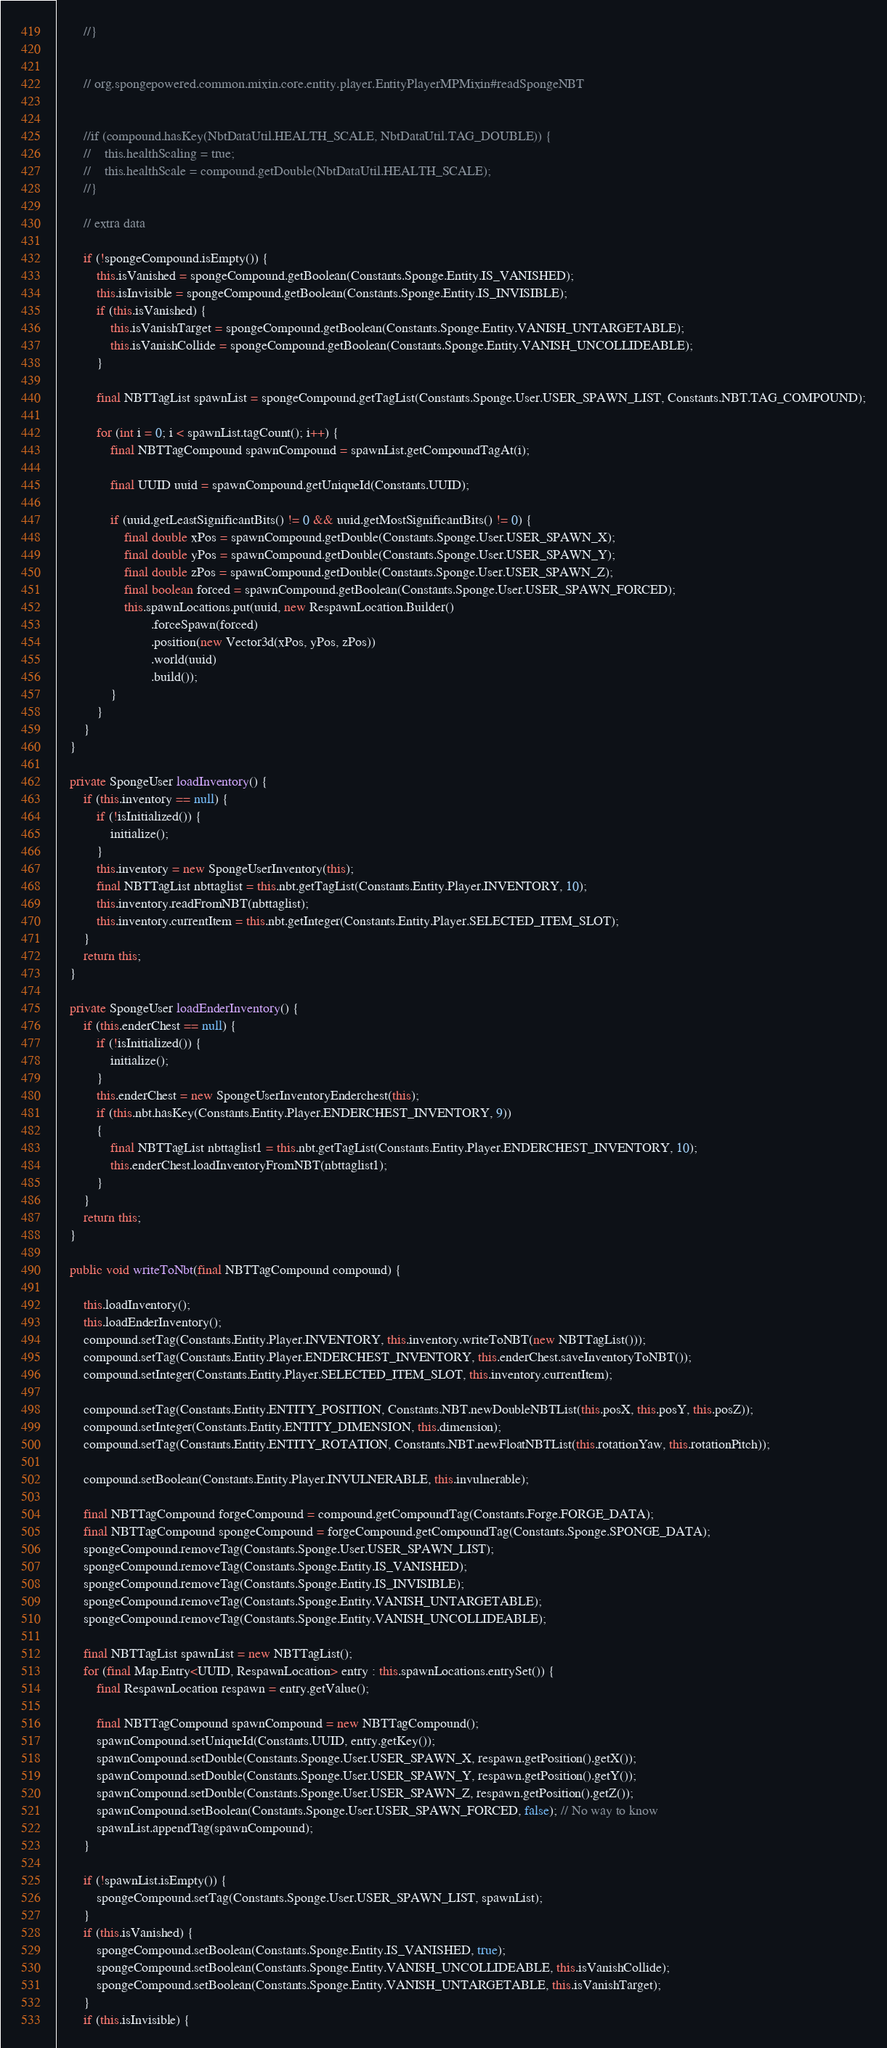Convert code to text. <code><loc_0><loc_0><loc_500><loc_500><_Java_>        //}


        // org.spongepowered.common.mixin.core.entity.player.EntityPlayerMPMixin#readSpongeNBT


        //if (compound.hasKey(NbtDataUtil.HEALTH_SCALE, NbtDataUtil.TAG_DOUBLE)) {
        //    this.healthScaling = true;
        //    this.healthScale = compound.getDouble(NbtDataUtil.HEALTH_SCALE);
        //}

        // extra data

        if (!spongeCompound.isEmpty()) {
            this.isVanished = spongeCompound.getBoolean(Constants.Sponge.Entity.IS_VANISHED);
            this.isInvisible = spongeCompound.getBoolean(Constants.Sponge.Entity.IS_INVISIBLE);
            if (this.isVanished) {
                this.isVanishTarget = spongeCompound.getBoolean(Constants.Sponge.Entity.VANISH_UNTARGETABLE);
                this.isVanishCollide = spongeCompound.getBoolean(Constants.Sponge.Entity.VANISH_UNCOLLIDEABLE);
            }

            final NBTTagList spawnList = spongeCompound.getTagList(Constants.Sponge.User.USER_SPAWN_LIST, Constants.NBT.TAG_COMPOUND);

            for (int i = 0; i < spawnList.tagCount(); i++) {
                final NBTTagCompound spawnCompound = spawnList.getCompoundTagAt(i);

                final UUID uuid = spawnCompound.getUniqueId(Constants.UUID);

                if (uuid.getLeastSignificantBits() != 0 && uuid.getMostSignificantBits() != 0) {
                    final double xPos = spawnCompound.getDouble(Constants.Sponge.User.USER_SPAWN_X);
                    final double yPos = spawnCompound.getDouble(Constants.Sponge.User.USER_SPAWN_Y);
                    final double zPos = spawnCompound.getDouble(Constants.Sponge.User.USER_SPAWN_Z);
                    final boolean forced = spawnCompound.getBoolean(Constants.Sponge.User.USER_SPAWN_FORCED);
                    this.spawnLocations.put(uuid, new RespawnLocation.Builder()
                            .forceSpawn(forced)
                            .position(new Vector3d(xPos, yPos, zPos))
                            .world(uuid)
                            .build());
                }
            }
        }
    }

    private SpongeUser loadInventory() {
        if (this.inventory == null) {
            if (!isInitialized()) {
                initialize();
            }
            this.inventory = new SpongeUserInventory(this);
            final NBTTagList nbttaglist = this.nbt.getTagList(Constants.Entity.Player.INVENTORY, 10);
            this.inventory.readFromNBT(nbttaglist);
            this.inventory.currentItem = this.nbt.getInteger(Constants.Entity.Player.SELECTED_ITEM_SLOT);
        }
        return this;
    }

    private SpongeUser loadEnderInventory() {
        if (this.enderChest == null) {
            if (!isInitialized()) {
                initialize();
            }
            this.enderChest = new SpongeUserInventoryEnderchest(this);
            if (this.nbt.hasKey(Constants.Entity.Player.ENDERCHEST_INVENTORY, 9))
            {
                final NBTTagList nbttaglist1 = this.nbt.getTagList(Constants.Entity.Player.ENDERCHEST_INVENTORY, 10);
                this.enderChest.loadInventoryFromNBT(nbttaglist1);
            }
        }
        return this;
    }

    public void writeToNbt(final NBTTagCompound compound) {

        this.loadInventory();
        this.loadEnderInventory();
        compound.setTag(Constants.Entity.Player.INVENTORY, this.inventory.writeToNBT(new NBTTagList()));
        compound.setTag(Constants.Entity.Player.ENDERCHEST_INVENTORY, this.enderChest.saveInventoryToNBT());
        compound.setInteger(Constants.Entity.Player.SELECTED_ITEM_SLOT, this.inventory.currentItem);

        compound.setTag(Constants.Entity.ENTITY_POSITION, Constants.NBT.newDoubleNBTList(this.posX, this.posY, this.posZ));
        compound.setInteger(Constants.Entity.ENTITY_DIMENSION, this.dimension);
        compound.setTag(Constants.Entity.ENTITY_ROTATION, Constants.NBT.newFloatNBTList(this.rotationYaw, this.rotationPitch));

        compound.setBoolean(Constants.Entity.Player.INVULNERABLE, this.invulnerable);

        final NBTTagCompound forgeCompound = compound.getCompoundTag(Constants.Forge.FORGE_DATA);
        final NBTTagCompound spongeCompound = forgeCompound.getCompoundTag(Constants.Sponge.SPONGE_DATA);
        spongeCompound.removeTag(Constants.Sponge.User.USER_SPAWN_LIST);
        spongeCompound.removeTag(Constants.Sponge.Entity.IS_VANISHED);
        spongeCompound.removeTag(Constants.Sponge.Entity.IS_INVISIBLE);
        spongeCompound.removeTag(Constants.Sponge.Entity.VANISH_UNTARGETABLE);
        spongeCompound.removeTag(Constants.Sponge.Entity.VANISH_UNCOLLIDEABLE);

        final NBTTagList spawnList = new NBTTagList();
        for (final Map.Entry<UUID, RespawnLocation> entry : this.spawnLocations.entrySet()) {
            final RespawnLocation respawn = entry.getValue();

            final NBTTagCompound spawnCompound = new NBTTagCompound();
            spawnCompound.setUniqueId(Constants.UUID, entry.getKey());
            spawnCompound.setDouble(Constants.Sponge.User.USER_SPAWN_X, respawn.getPosition().getX());
            spawnCompound.setDouble(Constants.Sponge.User.USER_SPAWN_Y, respawn.getPosition().getY());
            spawnCompound.setDouble(Constants.Sponge.User.USER_SPAWN_Z, respawn.getPosition().getZ());
            spawnCompound.setBoolean(Constants.Sponge.User.USER_SPAWN_FORCED, false); // No way to know
            spawnList.appendTag(spawnCompound);
        }

        if (!spawnList.isEmpty()) {
            spongeCompound.setTag(Constants.Sponge.User.USER_SPAWN_LIST, spawnList);
        }
        if (this.isVanished) {
            spongeCompound.setBoolean(Constants.Sponge.Entity.IS_VANISHED, true);
            spongeCompound.setBoolean(Constants.Sponge.Entity.VANISH_UNCOLLIDEABLE, this.isVanishCollide);
            spongeCompound.setBoolean(Constants.Sponge.Entity.VANISH_UNTARGETABLE, this.isVanishTarget);
        }
        if (this.isInvisible) {</code> 